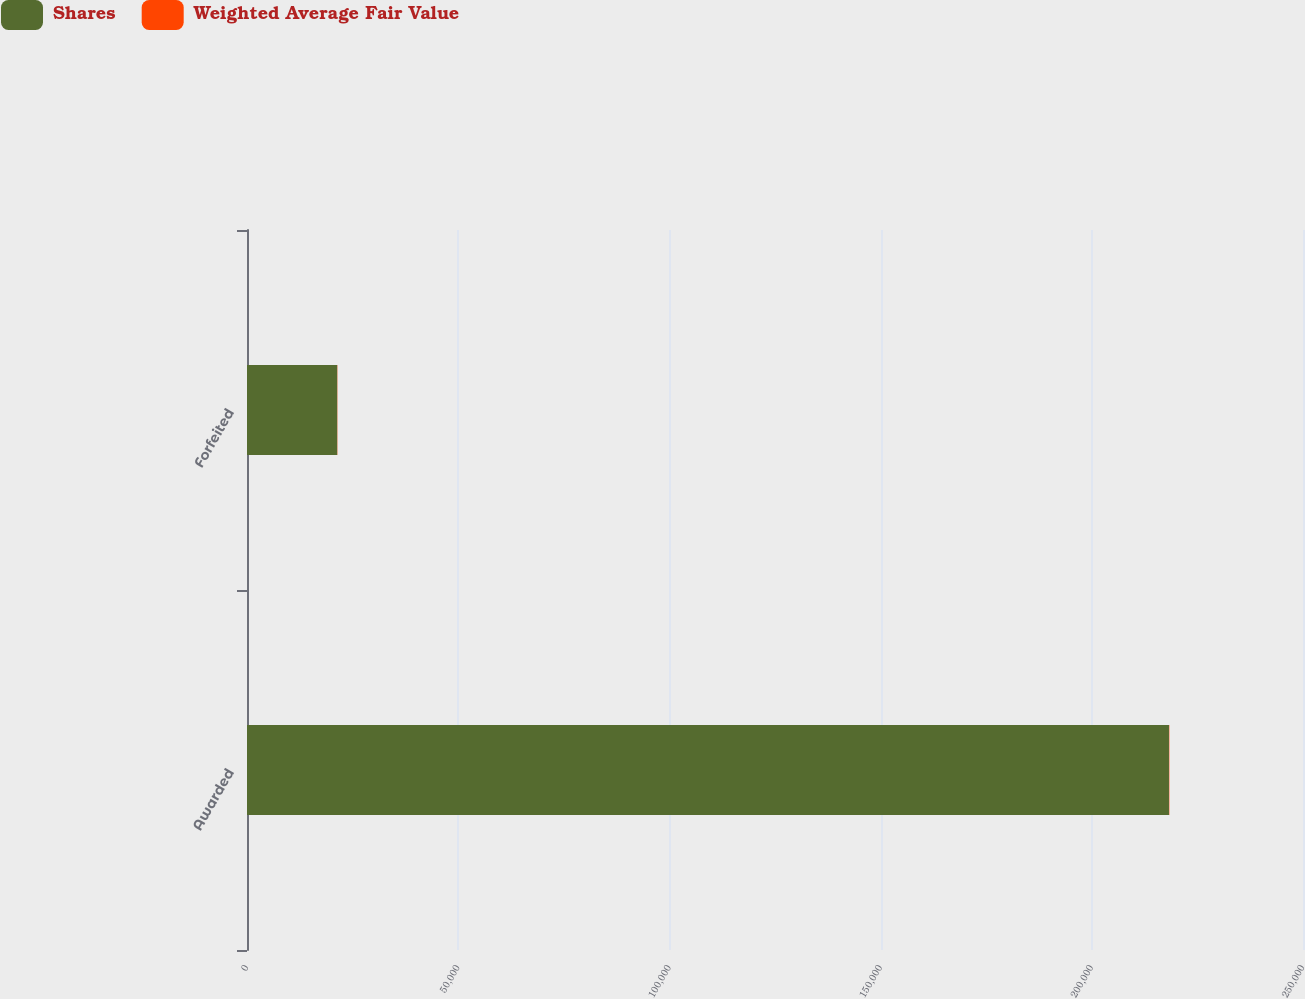Convert chart. <chart><loc_0><loc_0><loc_500><loc_500><stacked_bar_chart><ecel><fcel>Awarded<fcel>Forfeited<nl><fcel>Shares<fcel>218273<fcel>21354<nl><fcel>Weighted Average Fair Value<fcel>80.24<fcel>55.41<nl></chart> 